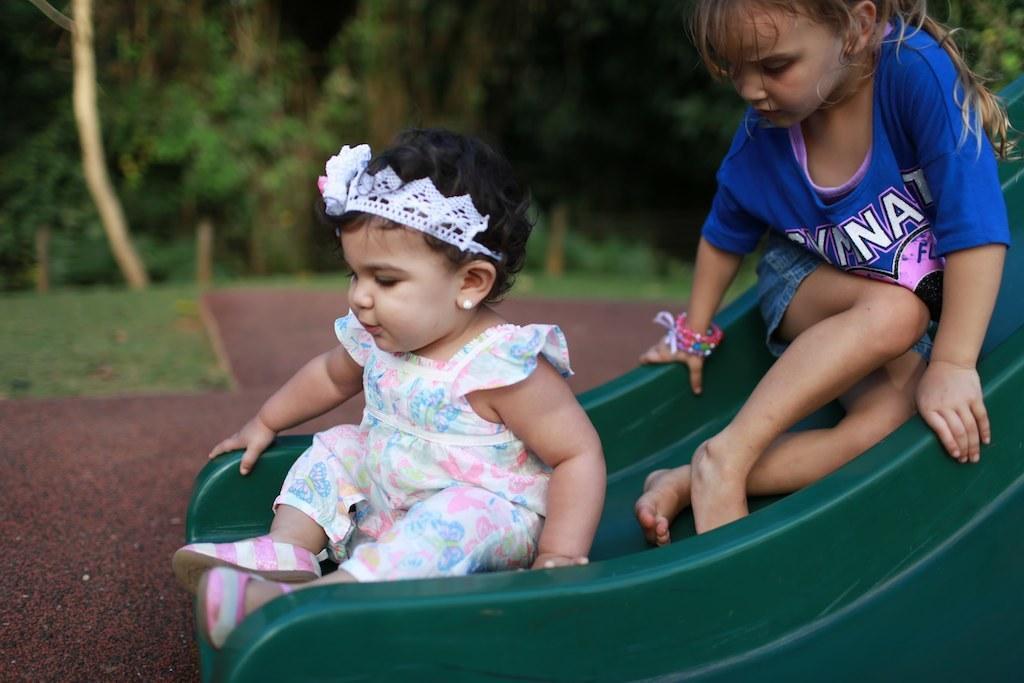Please provide a concise description of this image. In this image there are two kids sliding on the sliding board , and in the background there are trees, grass. 